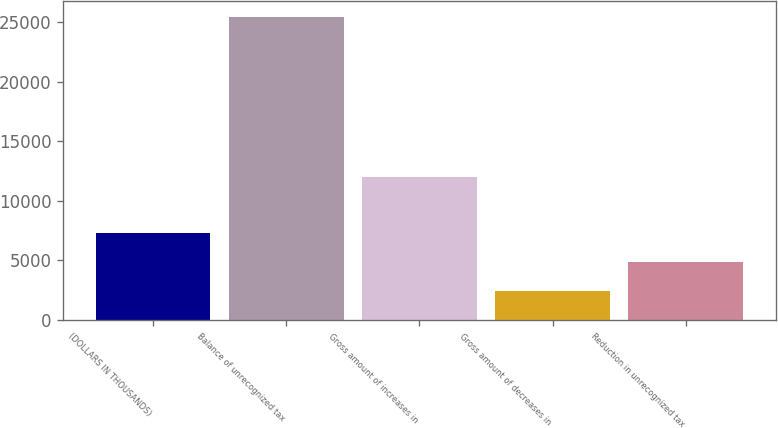Convert chart to OTSL. <chart><loc_0><loc_0><loc_500><loc_500><bar_chart><fcel>(DOLLARS IN THOUSANDS)<fcel>Balance of unrecognized tax<fcel>Gross amount of increases in<fcel>Gross amount of decreases in<fcel>Reduction in unrecognized tax<nl><fcel>7272<fcel>25473<fcel>12011<fcel>2436<fcel>4854<nl></chart> 